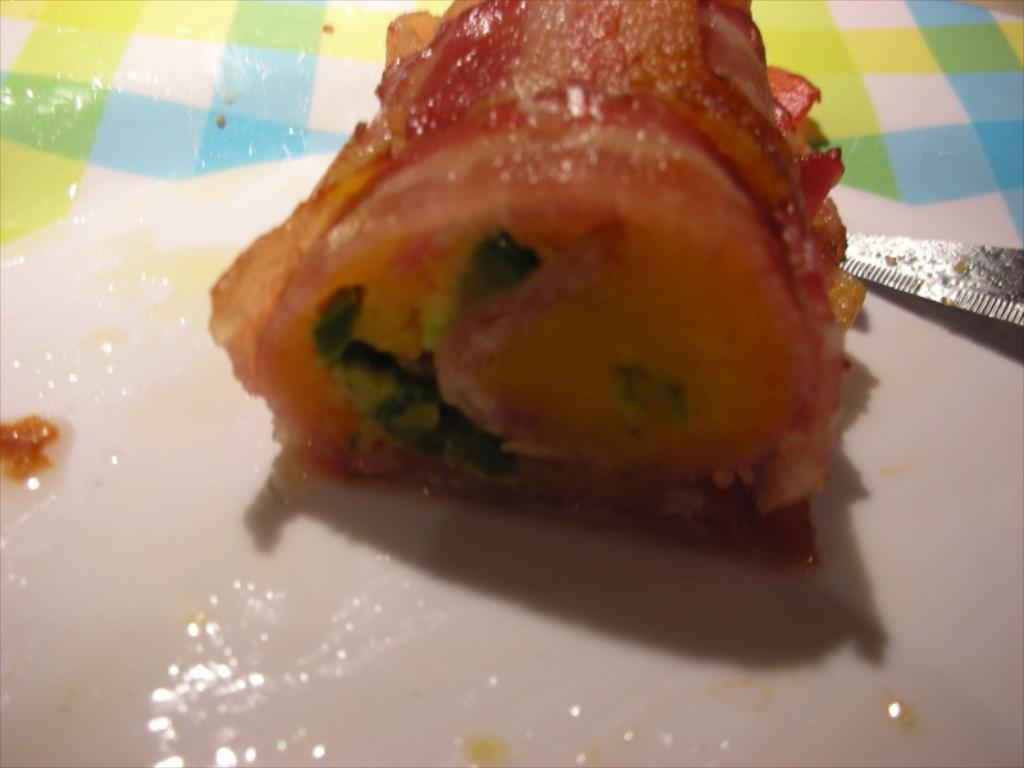What is on the plate in the image? There is food in the plate in the image. What utensil is placed near the plate in the image? There is a knife on the side of the plate in the image. What type of material is the cloth made of in the image? The cloth visible in the image is not specified, so we cannot determine its material. What type of meat is being served on the plate in the image? The type of food on the plate is not specified, so we cannot determine if it is meat or not. How does the cloth turn into a different color in the image? There is no indication of the cloth changing color in the image. 